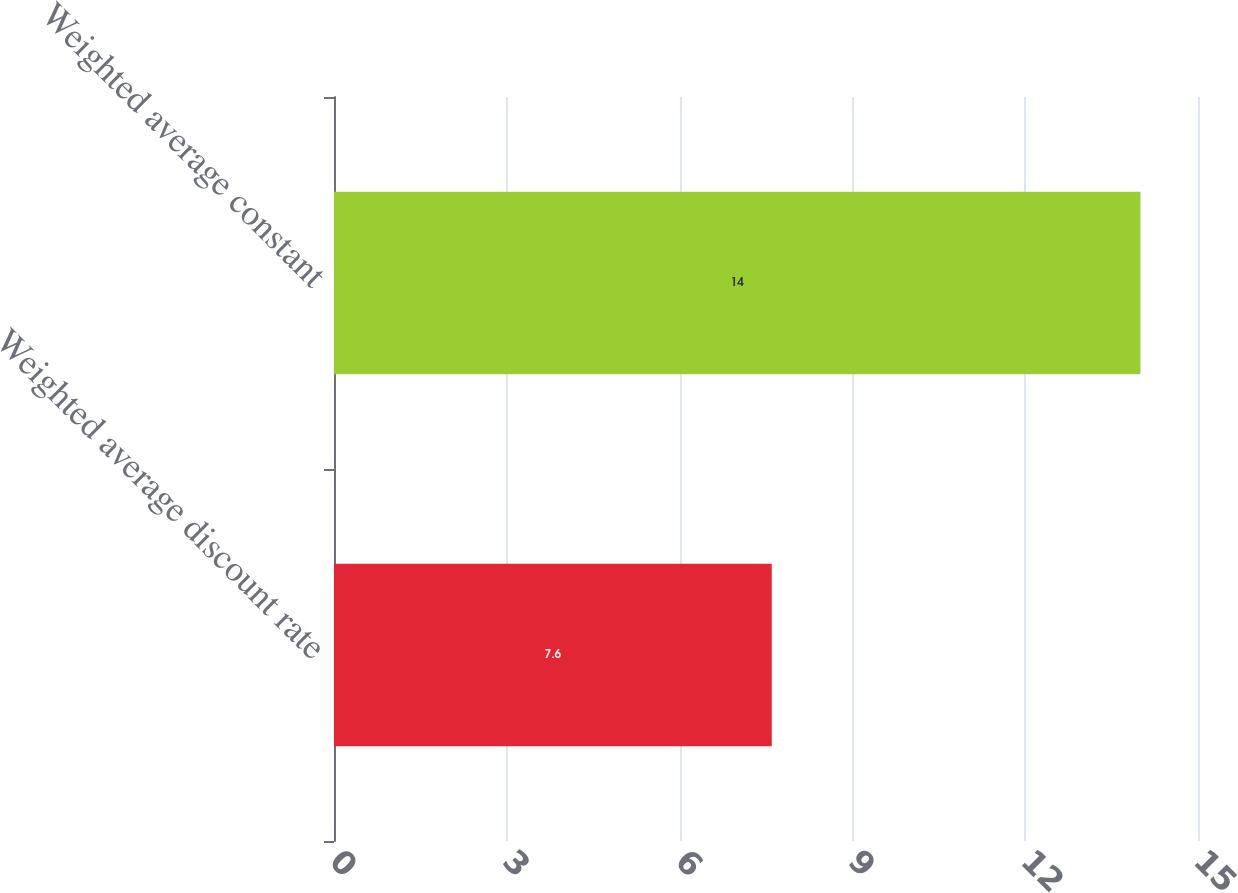Convert chart to OTSL. <chart><loc_0><loc_0><loc_500><loc_500><bar_chart><fcel>Weighted average discount rate<fcel>Weighted average constant<nl><fcel>7.6<fcel>14<nl></chart> 